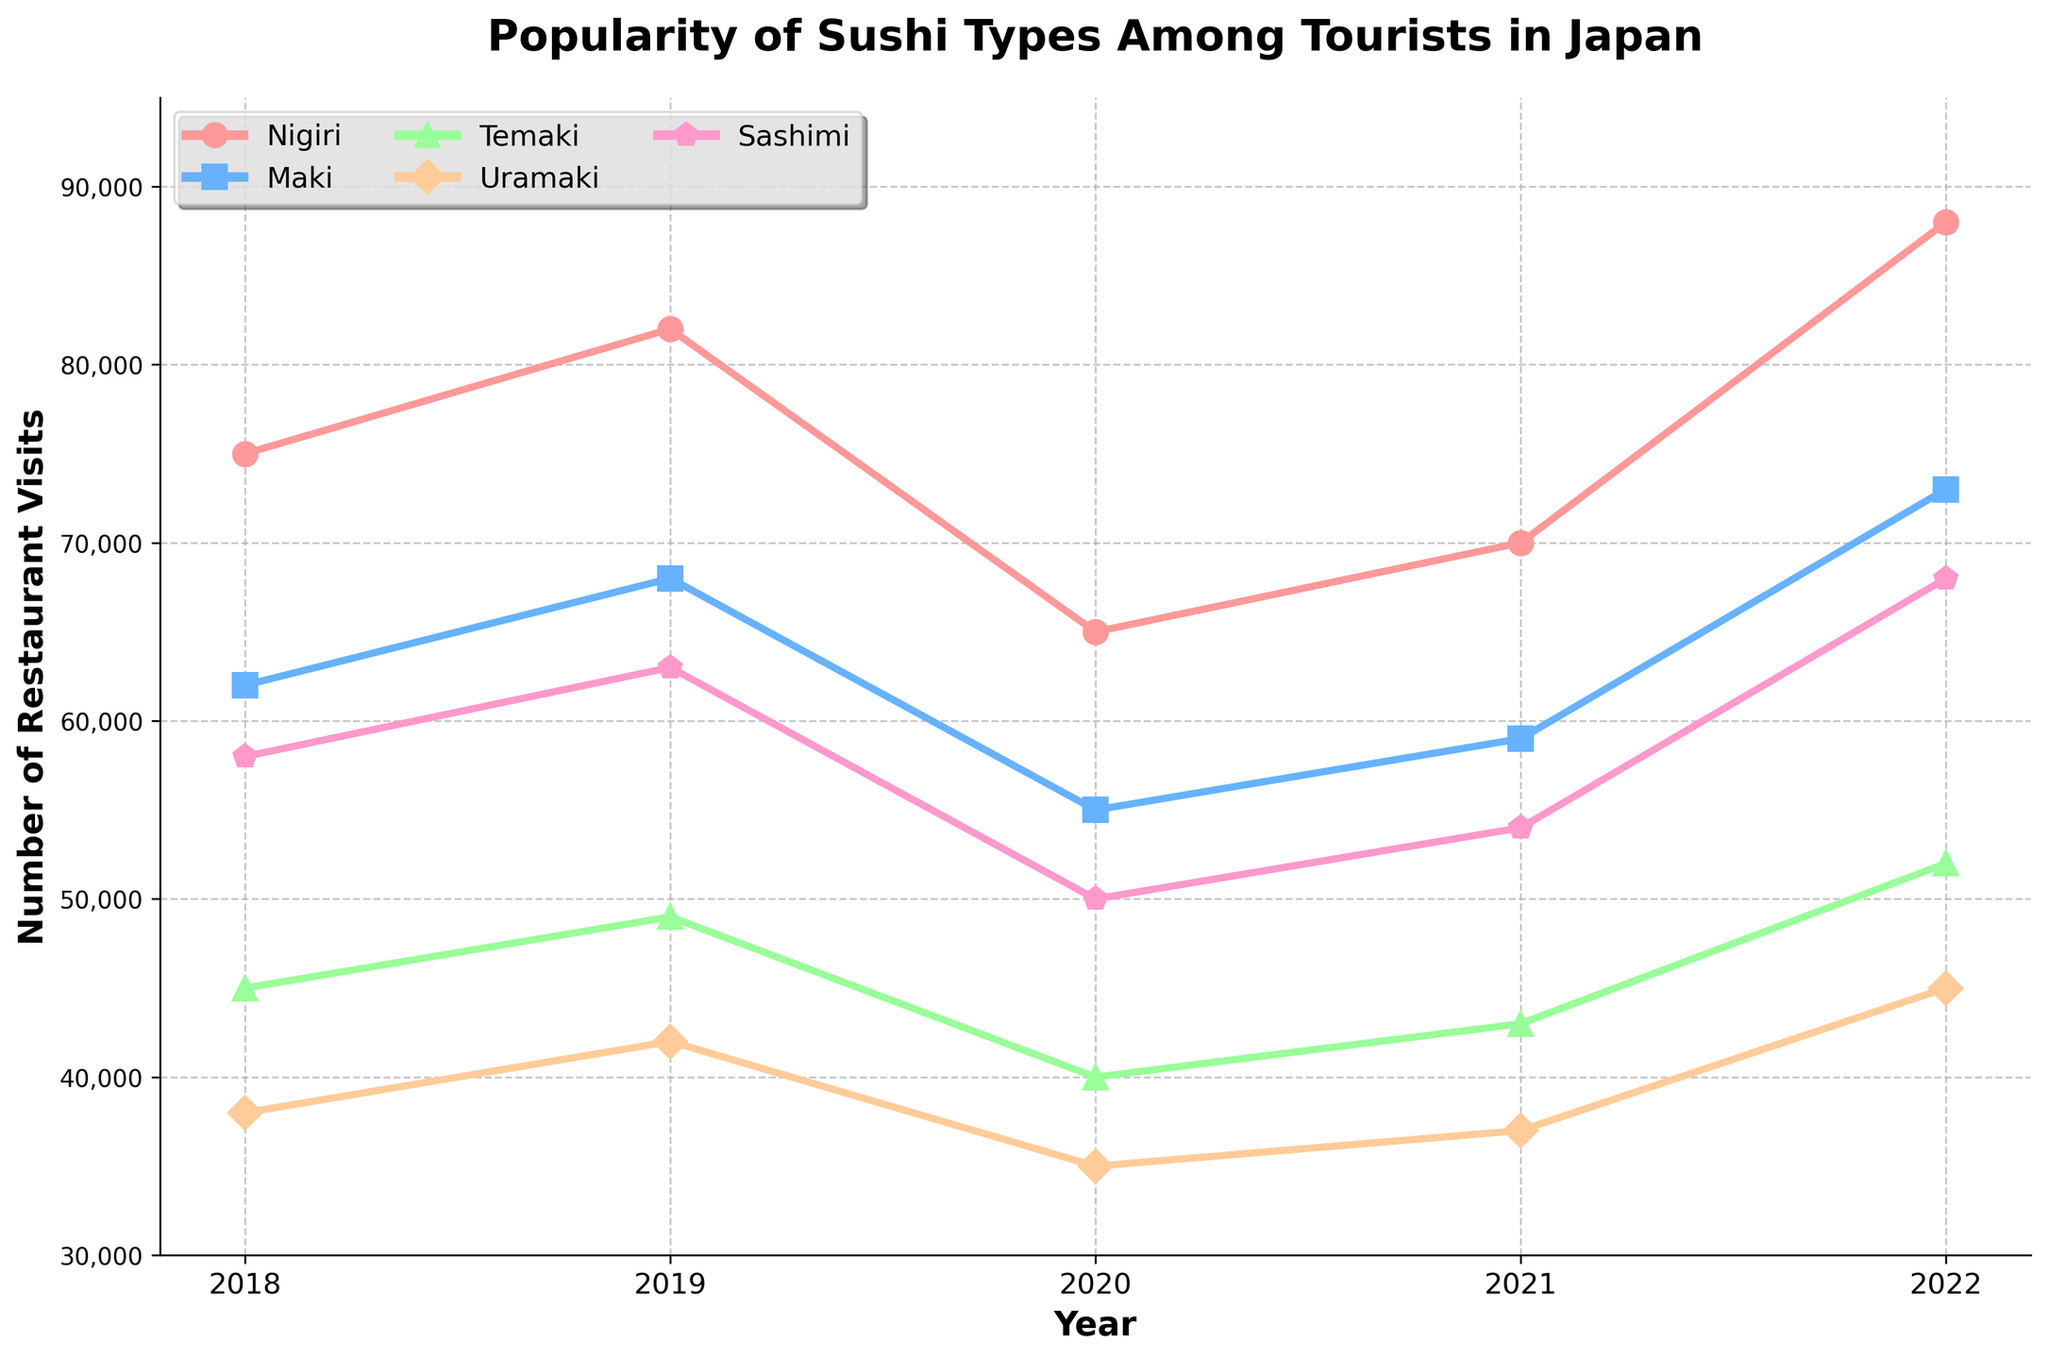what is the highest number of restaurant visits for a sushi type in any year? Compare the highest points across all lines in the figure. The highest number of restaurant visits is 88000 for Nigiri in 2022
Answer: 88000 Which type of sushi shows the most significant increase in popularity between 2021 and 2022? Look at the slope of each line from 2021 to 2022 and compare the differences. Nigiri shows the most significant increase, from 70000 to 88000, a rise of 18000 visits
Answer: Nigiri How does the popularity of Maki in 2019 compare to the popularity of Uramaki in 2022? Find and compare the relevant points. Maki in 2019 has 68000 visits while Uramaki in 2022 has 45000 visits.
Answer: Maki is more popular What is the total number of restaurant visits for Sashimi over the 5 years? Sum the Sashimi values from all the years: 58000 + 63000 + 50000 + 54000 + 68000 = 293000.
Answer: 293000 Did any type of sushi experience a decrease in popularity between 2018 and 2019? Compare the 2018 and 2019 values for each sushi type. No type shows a decrease, as all numbers have increased.
Answer: No Which sushi type had the lowest number of restaurant visits in 2021, and what was this number? Look at the values for 2021 and identify the smallest one. Temaki had the lowest number of visits with 43000.
Answer: Temaki, 43000 Comparing the popularity of Nigiri and Maki over the five years, which has a more consistent trend? Assess the trendlines for both Nigiri and Maki. Nigiri shows more fluctuations (increase, decrease, then increase sharply), while Maki shows a more steady increase except for 2020, making Maki more consistent.
Answer: Maki By how much did the restaurant visits for Temaki change from 2020 to 2022? Subtract the 2020 value from the 2022 value. Difference is 52000 - 40000 = 12000.
Answer: Increased by 12000 What color represents Sashimi on the chart? Identify the color used for the line corresponding to Sashimi. It is represented by a pink color.
Answer: Pink 